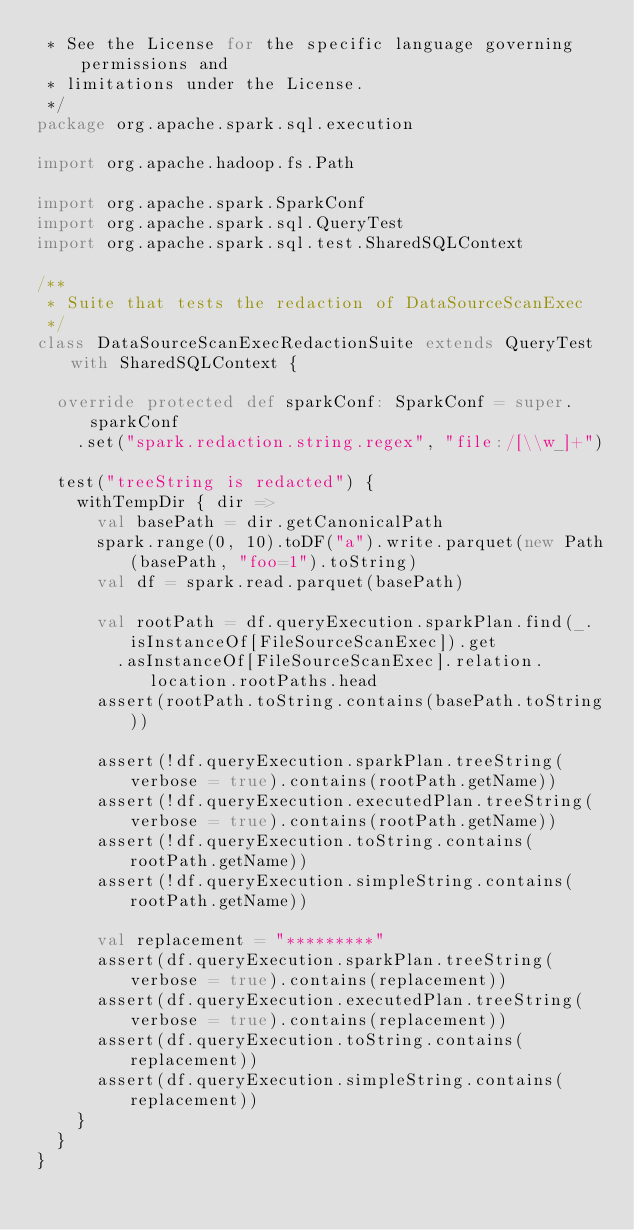<code> <loc_0><loc_0><loc_500><loc_500><_Scala_> * See the License for the specific language governing permissions and
 * limitations under the License.
 */
package org.apache.spark.sql.execution

import org.apache.hadoop.fs.Path

import org.apache.spark.SparkConf
import org.apache.spark.sql.QueryTest
import org.apache.spark.sql.test.SharedSQLContext

/**
 * Suite that tests the redaction of DataSourceScanExec
 */
class DataSourceScanExecRedactionSuite extends QueryTest with SharedSQLContext {

  override protected def sparkConf: SparkConf = super.sparkConf
    .set("spark.redaction.string.regex", "file:/[\\w_]+")

  test("treeString is redacted") {
    withTempDir { dir =>
      val basePath = dir.getCanonicalPath
      spark.range(0, 10).toDF("a").write.parquet(new Path(basePath, "foo=1").toString)
      val df = spark.read.parquet(basePath)

      val rootPath = df.queryExecution.sparkPlan.find(_.isInstanceOf[FileSourceScanExec]).get
        .asInstanceOf[FileSourceScanExec].relation.location.rootPaths.head
      assert(rootPath.toString.contains(basePath.toString))

      assert(!df.queryExecution.sparkPlan.treeString(verbose = true).contains(rootPath.getName))
      assert(!df.queryExecution.executedPlan.treeString(verbose = true).contains(rootPath.getName))
      assert(!df.queryExecution.toString.contains(rootPath.getName))
      assert(!df.queryExecution.simpleString.contains(rootPath.getName))

      val replacement = "*********"
      assert(df.queryExecution.sparkPlan.treeString(verbose = true).contains(replacement))
      assert(df.queryExecution.executedPlan.treeString(verbose = true).contains(replacement))
      assert(df.queryExecution.toString.contains(replacement))
      assert(df.queryExecution.simpleString.contains(replacement))
    }
  }
}
</code> 